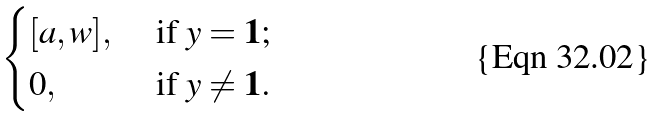<formula> <loc_0><loc_0><loc_500><loc_500>\begin{cases} [ a , w ] , \ & \text {if} \ y = \mathbf 1 ; \\ 0 , \ & \text {if} \ y \neq \mathbf 1 . \end{cases}</formula> 